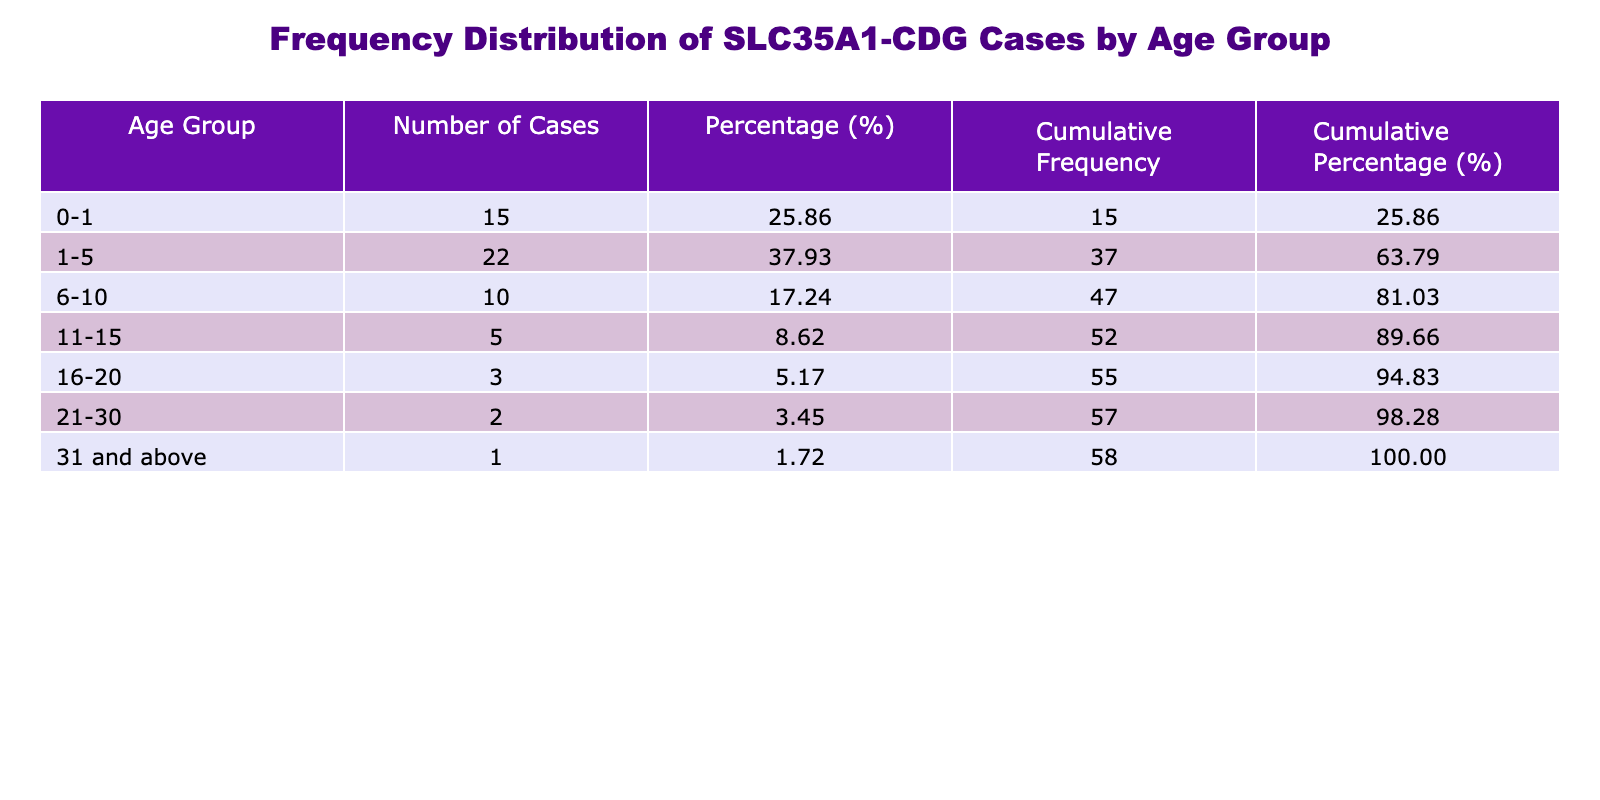What is the age group with the highest number of cases? By looking at the "Number of Cases" column, the age group labeled "1-5" has the highest number, with a total of 22 cases.
Answer: 1-5 What percentage of total cases are in the age group 0-1? The number of cases in the age group 0-1 is 15. The total number of cases is 78. To find the percentage, divide 15 by 78 and multiply by 100, which gives approximately 19.23%.
Answer: 19.23% How many more cases are there in the age group 1-5 compared to the age group 6-10? The age group 1-5 has 22 cases, and the age group 6-10 has 10 cases. The difference is calculated by subtracting: 22 - 10 = 12.
Answer: 12 Is there more than one case in the age group 31 and above? In the age group 31 and above, there is only 1 case listed. Therefore, the statement is false.
Answer: No What is the cumulative percentage of cases up to the age group 6-10? To find the cumulative percentage for the age group 6-10, first determine the cumulative number of cases: 15 (0-1) + 22 (1-5) + 10 (6-10) = 47. Next, divide 47 by the total 78 and multiply by 100 to get approximately 60.26%.
Answer: 60.26% What age groups have fewer than 5 cases? Looking at the numbers, the age groups with fewer than 5 cases are 16-20, 21-30, and 31 and above.
Answer: 16-20, 21-30, 31 and above What is the average number of cases across all age groups? To find the average, sum all the cases (15 + 22 + 10 + 5 + 3 + 2 + 1 = 78) and then divide by the number of age groups (7). So the average is 78 / 7, which equals approximately 11.14.
Answer: 11.14 Which age group constitutes more than 50% of total cases on its own? The age groups along with their cases are checked to see if any single group exceeds 39 cases (50% of 78). Since the largest group is 1-5 with 22 cases, none exceed 39.
Answer: No 